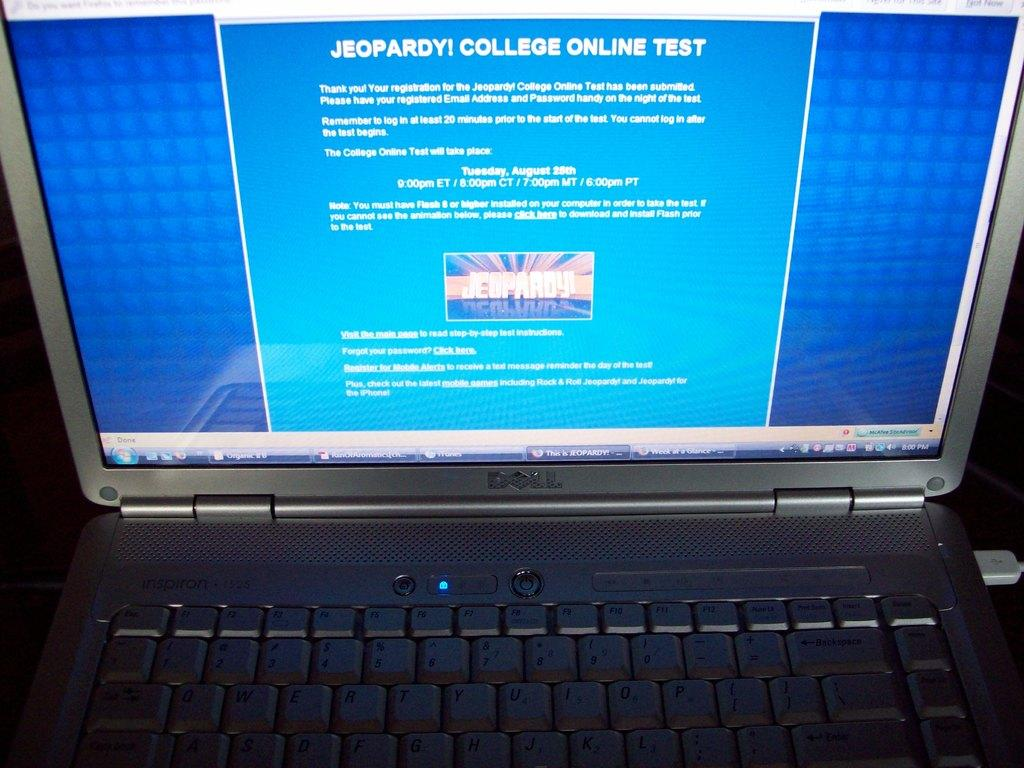<image>
Give a short and clear explanation of the subsequent image. Jeopardy, College Online Test is the header of the site shown on this laptop. 